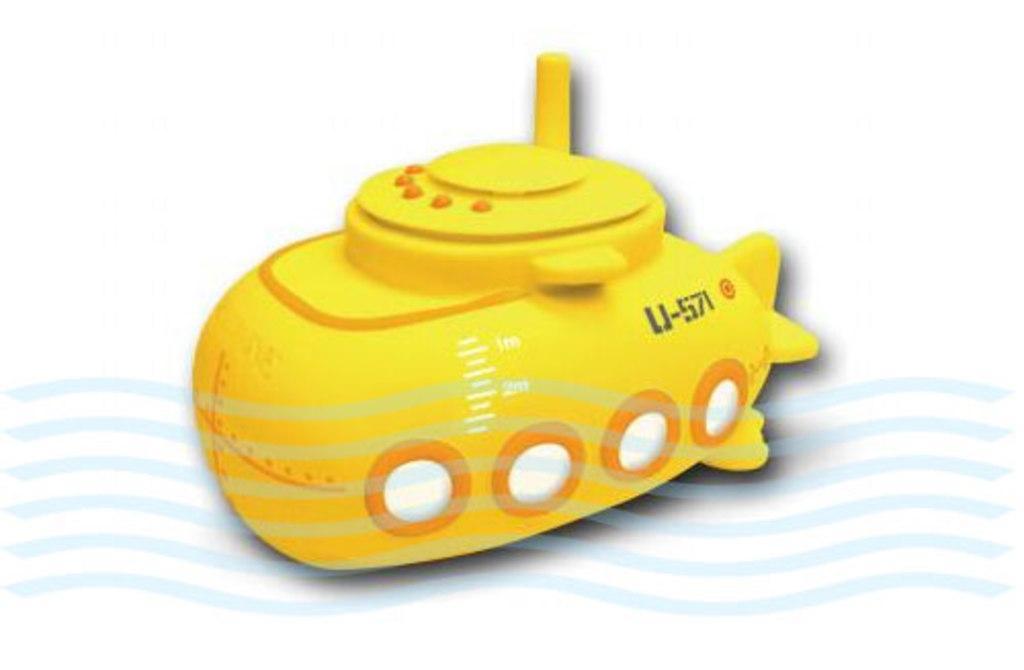Can you describe this image briefly? There is a toy vehicle in the center of the image and there is water mark at the bottom side. 